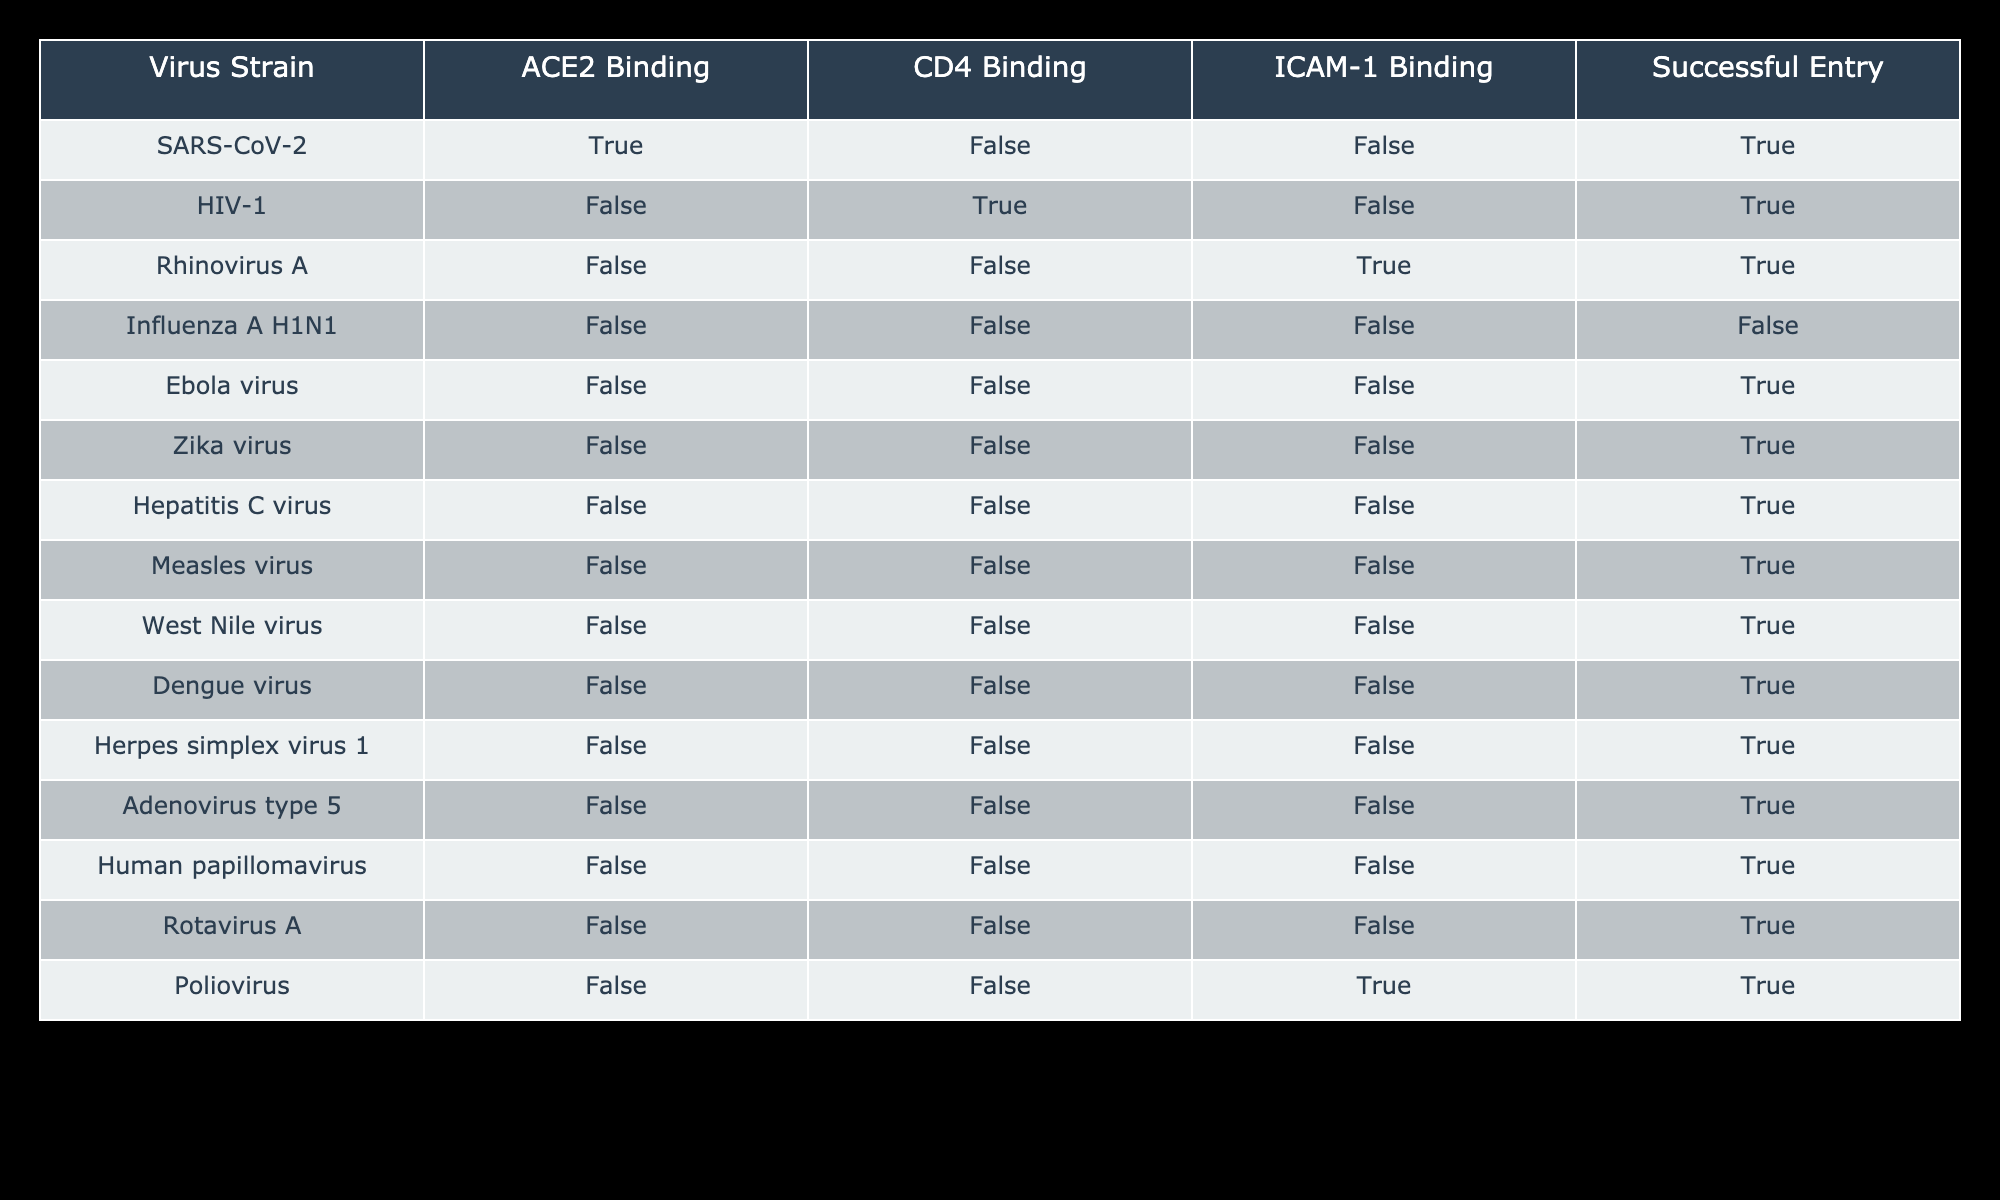What virus strain has successful entry while binding to ACE2? The table shows that SARS-CoV-2 is the only strain that binds to ACE2 and also has a successful entry.
Answer: SARS-CoV-2 Which virus strains bind to CD4? According to the table, only HIV-1 binds to CD4, while all other strains either do not bind or bind to other receptors.
Answer: HIV-1 How many virus strains successfully enter the host cell without binding to any of the listed receptors? The strains that successfully enter without binding to ACE2, CD4, or ICAM-1 are the Ebola virus, Zika virus, Hepatitis C virus, Measles virus, West Nile virus, Dengue virus, Herpes simplex virus 1, Adenovirus type 5, and Rotavirus A. This totals to 9 strains.
Answer: 9 Is there any virus strain that successfully enters but does not bind to any receptors? Yes, the Ebola virus, Zika virus, Hepatitis C virus, Measles virus, West Nile virus, Dengue virus, Herpes simplex virus 1, Adenovirus type 5, and Rotavirus A all successfully enter without binding to any receptors.
Answer: Yes What is the total number of virus strains that bind to ICAM-1? From the table, only Rhinovirus A and Poliovirus bind to ICAM-1. Thus, there are 2 strains that bind to this receptor.
Answer: 2 How many virus strains do not bind to ACE2, CD4, or ICAM-1 but still have successful entry? The table indicates 9 strains have successful entry without binding to ACE2, CD4, or ICAM-1. These strains are all the viruses listed under the second category of successful entry without receptor binding.
Answer: 9 Which strain binds to ICAM-1 and also has a successful entry? The table shows that both Rhinovirus A and Poliovirus bind to ICAM-1 and successfully enter the host cell.
Answer: Rhinovirus A, Poliovirus If we consider the virus strains that bind to receptors and those that do not, how many in total have a successful entry? The successful entry strains that bind receptors are SARS-CoV-2 (ACE2), HIV-1 (CD4), Rhinovirus A (ICAM-1), and Poliovirus (ICAM-1), while those without binding are the listed 9 strains. This gives a total of 13 strains that enter successfully.
Answer: 13 What percentage of virus strains bind to ACE2? The only virus strain that binds to ACE2 is SARS-CoV-2. Given a total of 15 virus strains, the percentage that binds to ACE2 is (1/15)*100 = 6.67%.
Answer: 6.67% 